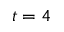<formula> <loc_0><loc_0><loc_500><loc_500>t = 4</formula> 